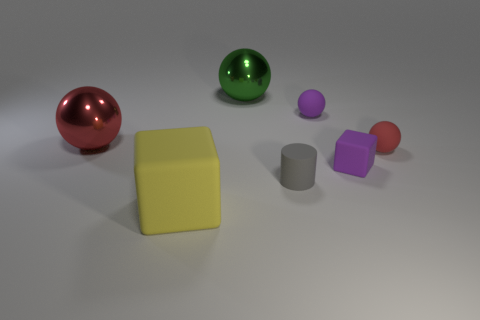How many objects are in this image, and can you describe their colors? There are six objects in the image, comprising two spheres, a large cube, a cylinder, and two smaller cubes. The spheres are red and green; the large cube is a muted yellow; the cylinder is gray; and the smaller cubes are purple and pink. Which object appears to be the largest? The yellow cube seems to be the largest object in terms of volume in the scene. 